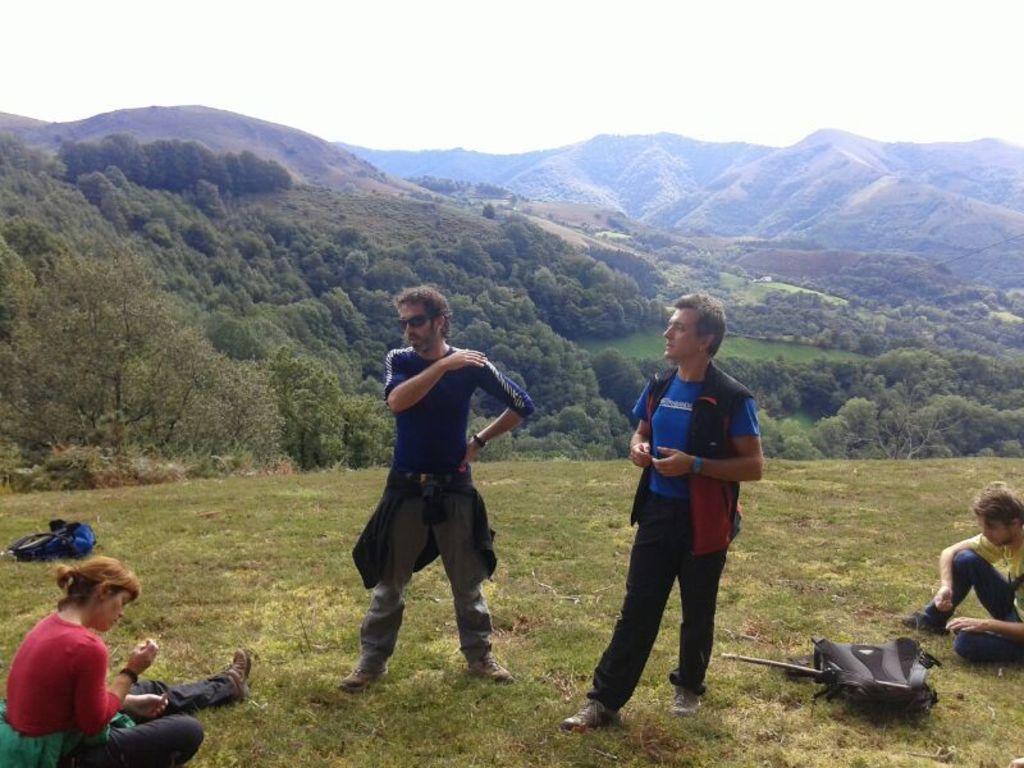How would you summarize this image in a sentence or two? In this picture we can see bags, two men standing, two people sitting on the grass and some objects and in the background we can see trees, mountains and the sky. 